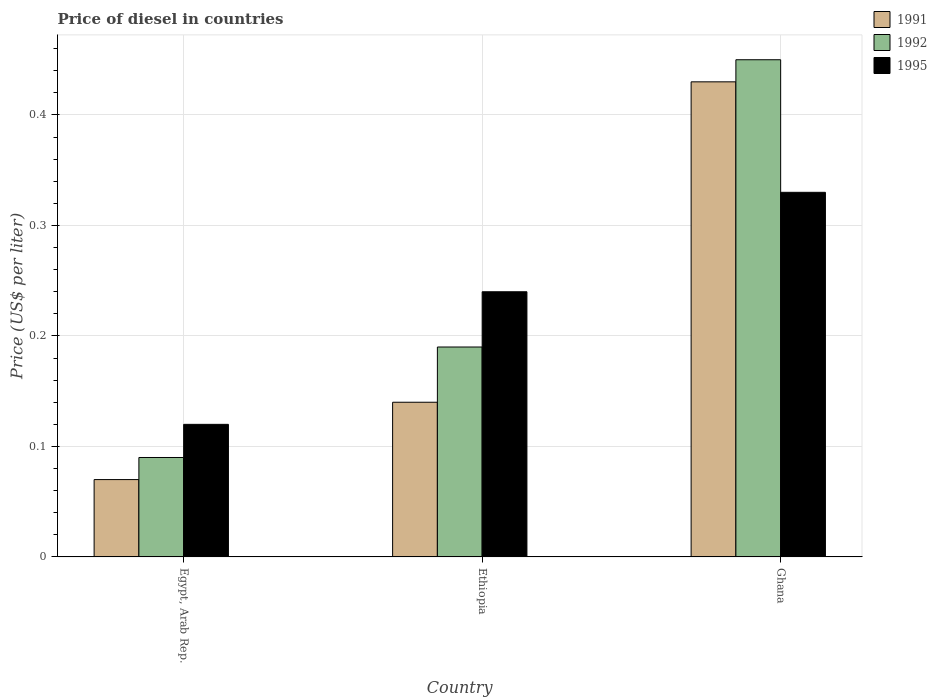How many different coloured bars are there?
Provide a succinct answer. 3. How many groups of bars are there?
Provide a succinct answer. 3. Are the number of bars per tick equal to the number of legend labels?
Give a very brief answer. Yes. What is the label of the 3rd group of bars from the left?
Give a very brief answer. Ghana. What is the price of diesel in 1995 in Egypt, Arab Rep.?
Ensure brevity in your answer.  0.12. Across all countries, what is the maximum price of diesel in 1995?
Offer a terse response. 0.33. Across all countries, what is the minimum price of diesel in 1992?
Your answer should be compact. 0.09. In which country was the price of diesel in 1991 minimum?
Your response must be concise. Egypt, Arab Rep. What is the total price of diesel in 1992 in the graph?
Your answer should be very brief. 0.73. What is the difference between the price of diesel in 1992 in Ethiopia and that in Ghana?
Your answer should be very brief. -0.26. What is the difference between the price of diesel in 1991 in Ethiopia and the price of diesel in 1995 in Ghana?
Your response must be concise. -0.19. What is the average price of diesel in 1995 per country?
Offer a terse response. 0.23. What is the difference between the price of diesel of/in 1991 and price of diesel of/in 1995 in Ghana?
Keep it short and to the point. 0.1. In how many countries, is the price of diesel in 1992 greater than 0.08 US$?
Your answer should be very brief. 3. Is the difference between the price of diesel in 1991 in Egypt, Arab Rep. and Ghana greater than the difference between the price of diesel in 1995 in Egypt, Arab Rep. and Ghana?
Offer a very short reply. No. What is the difference between the highest and the second highest price of diesel in 1991?
Your response must be concise. 0.29. What is the difference between the highest and the lowest price of diesel in 1995?
Give a very brief answer. 0.21. In how many countries, is the price of diesel in 1995 greater than the average price of diesel in 1995 taken over all countries?
Offer a terse response. 2. What does the 2nd bar from the left in Ethiopia represents?
Give a very brief answer. 1992. How many bars are there?
Offer a terse response. 9. Are all the bars in the graph horizontal?
Keep it short and to the point. No. How many countries are there in the graph?
Ensure brevity in your answer.  3. Does the graph contain any zero values?
Keep it short and to the point. No. Does the graph contain grids?
Your answer should be compact. Yes. Where does the legend appear in the graph?
Your response must be concise. Top right. How are the legend labels stacked?
Provide a short and direct response. Vertical. What is the title of the graph?
Ensure brevity in your answer.  Price of diesel in countries. What is the label or title of the Y-axis?
Make the answer very short. Price (US$ per liter). What is the Price (US$ per liter) of 1991 in Egypt, Arab Rep.?
Keep it short and to the point. 0.07. What is the Price (US$ per liter) in 1992 in Egypt, Arab Rep.?
Your answer should be compact. 0.09. What is the Price (US$ per liter) of 1995 in Egypt, Arab Rep.?
Provide a succinct answer. 0.12. What is the Price (US$ per liter) in 1991 in Ethiopia?
Your answer should be very brief. 0.14. What is the Price (US$ per liter) of 1992 in Ethiopia?
Provide a succinct answer. 0.19. What is the Price (US$ per liter) of 1995 in Ethiopia?
Ensure brevity in your answer.  0.24. What is the Price (US$ per liter) of 1991 in Ghana?
Your response must be concise. 0.43. What is the Price (US$ per liter) of 1992 in Ghana?
Your answer should be compact. 0.45. What is the Price (US$ per liter) of 1995 in Ghana?
Provide a succinct answer. 0.33. Across all countries, what is the maximum Price (US$ per liter) of 1991?
Provide a succinct answer. 0.43. Across all countries, what is the maximum Price (US$ per liter) of 1992?
Provide a succinct answer. 0.45. Across all countries, what is the maximum Price (US$ per liter) in 1995?
Provide a short and direct response. 0.33. Across all countries, what is the minimum Price (US$ per liter) in 1991?
Your answer should be compact. 0.07. Across all countries, what is the minimum Price (US$ per liter) in 1992?
Offer a very short reply. 0.09. Across all countries, what is the minimum Price (US$ per liter) of 1995?
Your answer should be compact. 0.12. What is the total Price (US$ per liter) in 1991 in the graph?
Offer a terse response. 0.64. What is the total Price (US$ per liter) in 1992 in the graph?
Keep it short and to the point. 0.73. What is the total Price (US$ per liter) of 1995 in the graph?
Offer a terse response. 0.69. What is the difference between the Price (US$ per liter) in 1991 in Egypt, Arab Rep. and that in Ethiopia?
Give a very brief answer. -0.07. What is the difference between the Price (US$ per liter) of 1992 in Egypt, Arab Rep. and that in Ethiopia?
Provide a succinct answer. -0.1. What is the difference between the Price (US$ per liter) in 1995 in Egypt, Arab Rep. and that in Ethiopia?
Make the answer very short. -0.12. What is the difference between the Price (US$ per liter) in 1991 in Egypt, Arab Rep. and that in Ghana?
Give a very brief answer. -0.36. What is the difference between the Price (US$ per liter) in 1992 in Egypt, Arab Rep. and that in Ghana?
Your answer should be very brief. -0.36. What is the difference between the Price (US$ per liter) in 1995 in Egypt, Arab Rep. and that in Ghana?
Keep it short and to the point. -0.21. What is the difference between the Price (US$ per liter) in 1991 in Ethiopia and that in Ghana?
Your answer should be very brief. -0.29. What is the difference between the Price (US$ per liter) in 1992 in Ethiopia and that in Ghana?
Provide a short and direct response. -0.26. What is the difference between the Price (US$ per liter) of 1995 in Ethiopia and that in Ghana?
Offer a very short reply. -0.09. What is the difference between the Price (US$ per liter) of 1991 in Egypt, Arab Rep. and the Price (US$ per liter) of 1992 in Ethiopia?
Provide a short and direct response. -0.12. What is the difference between the Price (US$ per liter) in 1991 in Egypt, Arab Rep. and the Price (US$ per liter) in 1995 in Ethiopia?
Ensure brevity in your answer.  -0.17. What is the difference between the Price (US$ per liter) in 1992 in Egypt, Arab Rep. and the Price (US$ per liter) in 1995 in Ethiopia?
Your answer should be very brief. -0.15. What is the difference between the Price (US$ per liter) in 1991 in Egypt, Arab Rep. and the Price (US$ per liter) in 1992 in Ghana?
Make the answer very short. -0.38. What is the difference between the Price (US$ per liter) of 1991 in Egypt, Arab Rep. and the Price (US$ per liter) of 1995 in Ghana?
Your response must be concise. -0.26. What is the difference between the Price (US$ per liter) of 1992 in Egypt, Arab Rep. and the Price (US$ per liter) of 1995 in Ghana?
Offer a very short reply. -0.24. What is the difference between the Price (US$ per liter) of 1991 in Ethiopia and the Price (US$ per liter) of 1992 in Ghana?
Your response must be concise. -0.31. What is the difference between the Price (US$ per liter) of 1991 in Ethiopia and the Price (US$ per liter) of 1995 in Ghana?
Give a very brief answer. -0.19. What is the difference between the Price (US$ per liter) of 1992 in Ethiopia and the Price (US$ per liter) of 1995 in Ghana?
Ensure brevity in your answer.  -0.14. What is the average Price (US$ per liter) of 1991 per country?
Provide a short and direct response. 0.21. What is the average Price (US$ per liter) in 1992 per country?
Your answer should be compact. 0.24. What is the average Price (US$ per liter) of 1995 per country?
Keep it short and to the point. 0.23. What is the difference between the Price (US$ per liter) of 1991 and Price (US$ per liter) of 1992 in Egypt, Arab Rep.?
Your answer should be compact. -0.02. What is the difference between the Price (US$ per liter) in 1992 and Price (US$ per liter) in 1995 in Egypt, Arab Rep.?
Make the answer very short. -0.03. What is the difference between the Price (US$ per liter) in 1991 and Price (US$ per liter) in 1995 in Ethiopia?
Offer a very short reply. -0.1. What is the difference between the Price (US$ per liter) of 1991 and Price (US$ per liter) of 1992 in Ghana?
Give a very brief answer. -0.02. What is the difference between the Price (US$ per liter) in 1992 and Price (US$ per liter) in 1995 in Ghana?
Your answer should be very brief. 0.12. What is the ratio of the Price (US$ per liter) of 1992 in Egypt, Arab Rep. to that in Ethiopia?
Ensure brevity in your answer.  0.47. What is the ratio of the Price (US$ per liter) of 1991 in Egypt, Arab Rep. to that in Ghana?
Provide a succinct answer. 0.16. What is the ratio of the Price (US$ per liter) in 1992 in Egypt, Arab Rep. to that in Ghana?
Make the answer very short. 0.2. What is the ratio of the Price (US$ per liter) in 1995 in Egypt, Arab Rep. to that in Ghana?
Your response must be concise. 0.36. What is the ratio of the Price (US$ per liter) in 1991 in Ethiopia to that in Ghana?
Ensure brevity in your answer.  0.33. What is the ratio of the Price (US$ per liter) in 1992 in Ethiopia to that in Ghana?
Your answer should be very brief. 0.42. What is the ratio of the Price (US$ per liter) of 1995 in Ethiopia to that in Ghana?
Your answer should be very brief. 0.73. What is the difference between the highest and the second highest Price (US$ per liter) of 1991?
Provide a short and direct response. 0.29. What is the difference between the highest and the second highest Price (US$ per liter) in 1992?
Provide a succinct answer. 0.26. What is the difference between the highest and the second highest Price (US$ per liter) of 1995?
Ensure brevity in your answer.  0.09. What is the difference between the highest and the lowest Price (US$ per liter) of 1991?
Offer a very short reply. 0.36. What is the difference between the highest and the lowest Price (US$ per liter) of 1992?
Provide a succinct answer. 0.36. What is the difference between the highest and the lowest Price (US$ per liter) of 1995?
Provide a succinct answer. 0.21. 